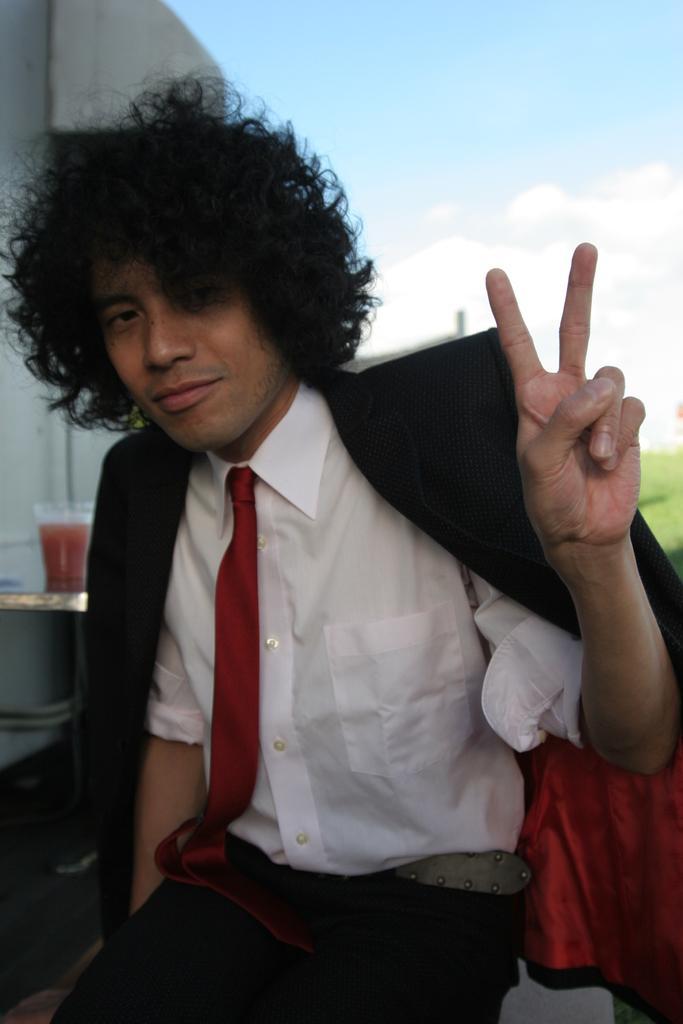Describe this image in one or two sentences. In this image we can see a person wearing white shirt, black coat and a red color tie, behind the person there is a glass with some drink and in the background there is a sky. 